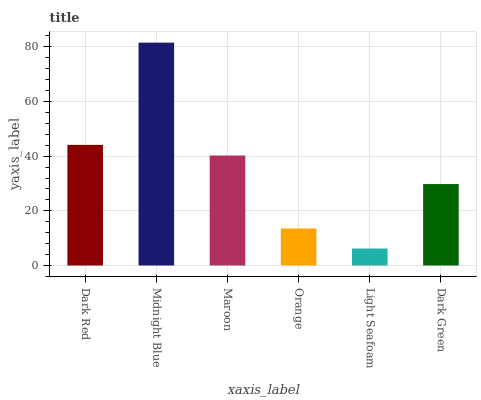Is Light Seafoam the minimum?
Answer yes or no. Yes. Is Midnight Blue the maximum?
Answer yes or no. Yes. Is Maroon the minimum?
Answer yes or no. No. Is Maroon the maximum?
Answer yes or no. No. Is Midnight Blue greater than Maroon?
Answer yes or no. Yes. Is Maroon less than Midnight Blue?
Answer yes or no. Yes. Is Maroon greater than Midnight Blue?
Answer yes or no. No. Is Midnight Blue less than Maroon?
Answer yes or no. No. Is Maroon the high median?
Answer yes or no. Yes. Is Dark Green the low median?
Answer yes or no. Yes. Is Dark Red the high median?
Answer yes or no. No. Is Dark Red the low median?
Answer yes or no. No. 